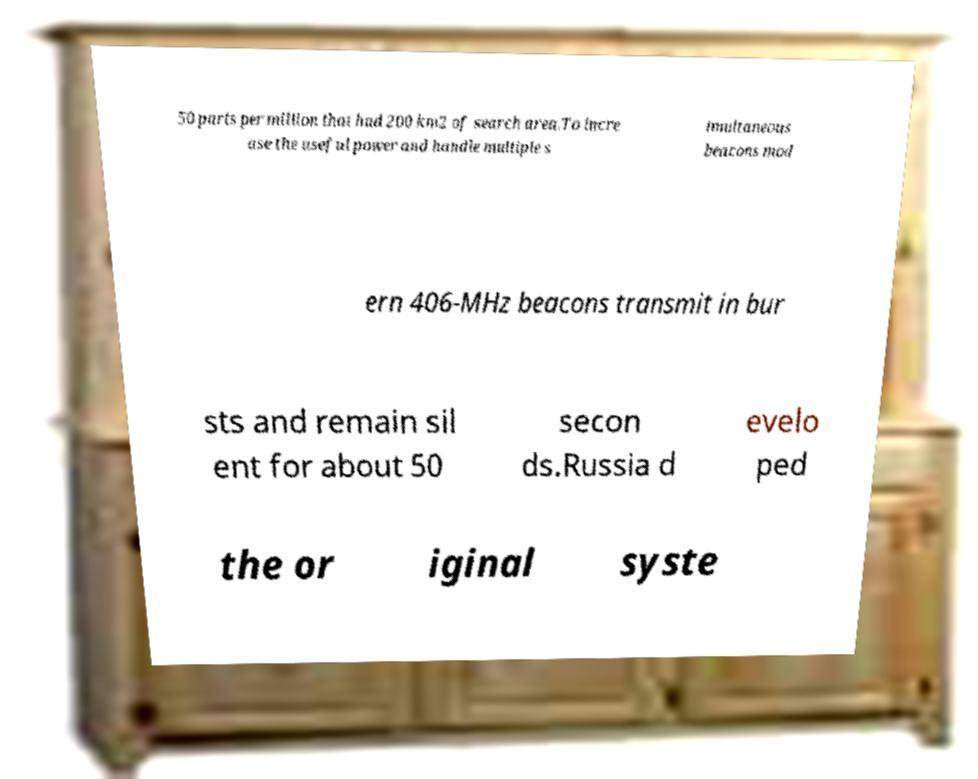Please identify and transcribe the text found in this image. 50 parts per million that had 200 km2 of search area.To incre ase the useful power and handle multiple s imultaneous beacons mod ern 406-MHz beacons transmit in bur sts and remain sil ent for about 50 secon ds.Russia d evelo ped the or iginal syste 